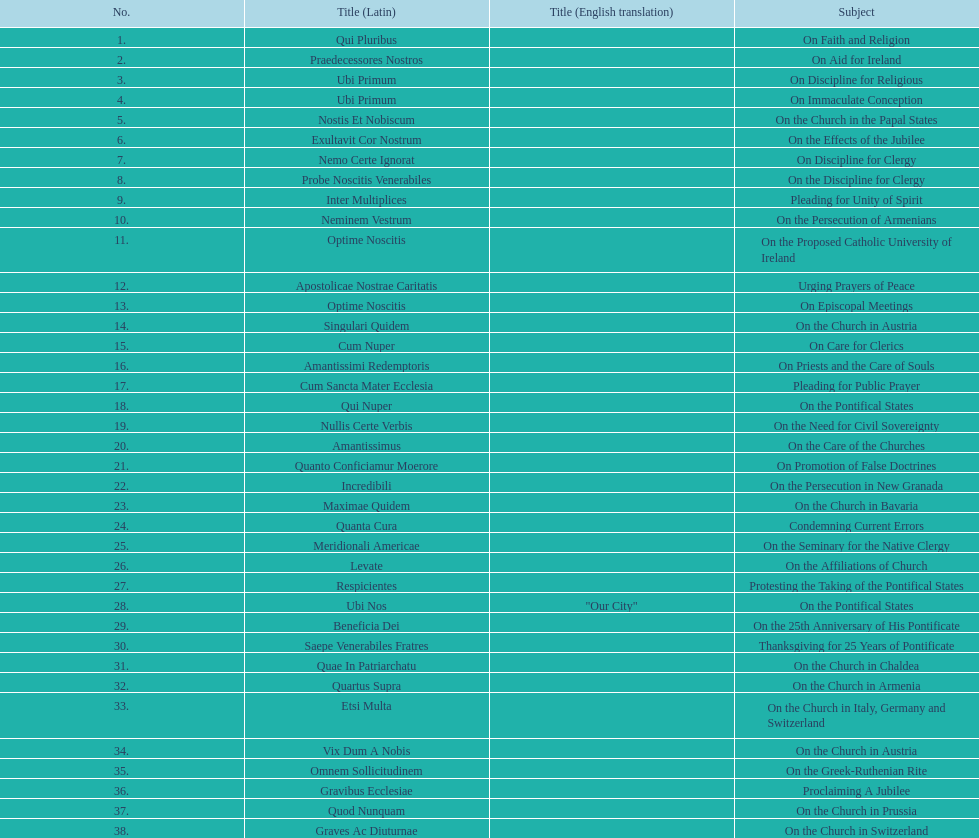What is the previous subject after on the effects of the jubilee? On the Church in the Papal States. 